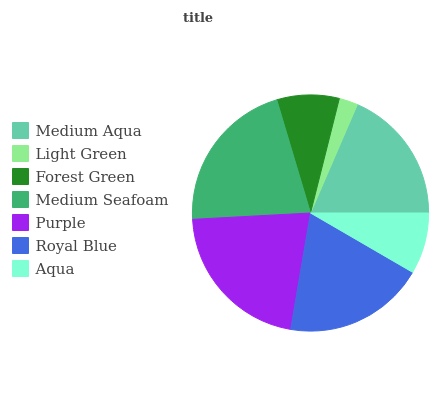Is Light Green the minimum?
Answer yes or no. Yes. Is Purple the maximum?
Answer yes or no. Yes. Is Forest Green the minimum?
Answer yes or no. No. Is Forest Green the maximum?
Answer yes or no. No. Is Forest Green greater than Light Green?
Answer yes or no. Yes. Is Light Green less than Forest Green?
Answer yes or no. Yes. Is Light Green greater than Forest Green?
Answer yes or no. No. Is Forest Green less than Light Green?
Answer yes or no. No. Is Medium Aqua the high median?
Answer yes or no. Yes. Is Medium Aqua the low median?
Answer yes or no. Yes. Is Royal Blue the high median?
Answer yes or no. No. Is Light Green the low median?
Answer yes or no. No. 